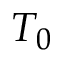Convert formula to latex. <formula><loc_0><loc_0><loc_500><loc_500>T _ { 0 }</formula> 